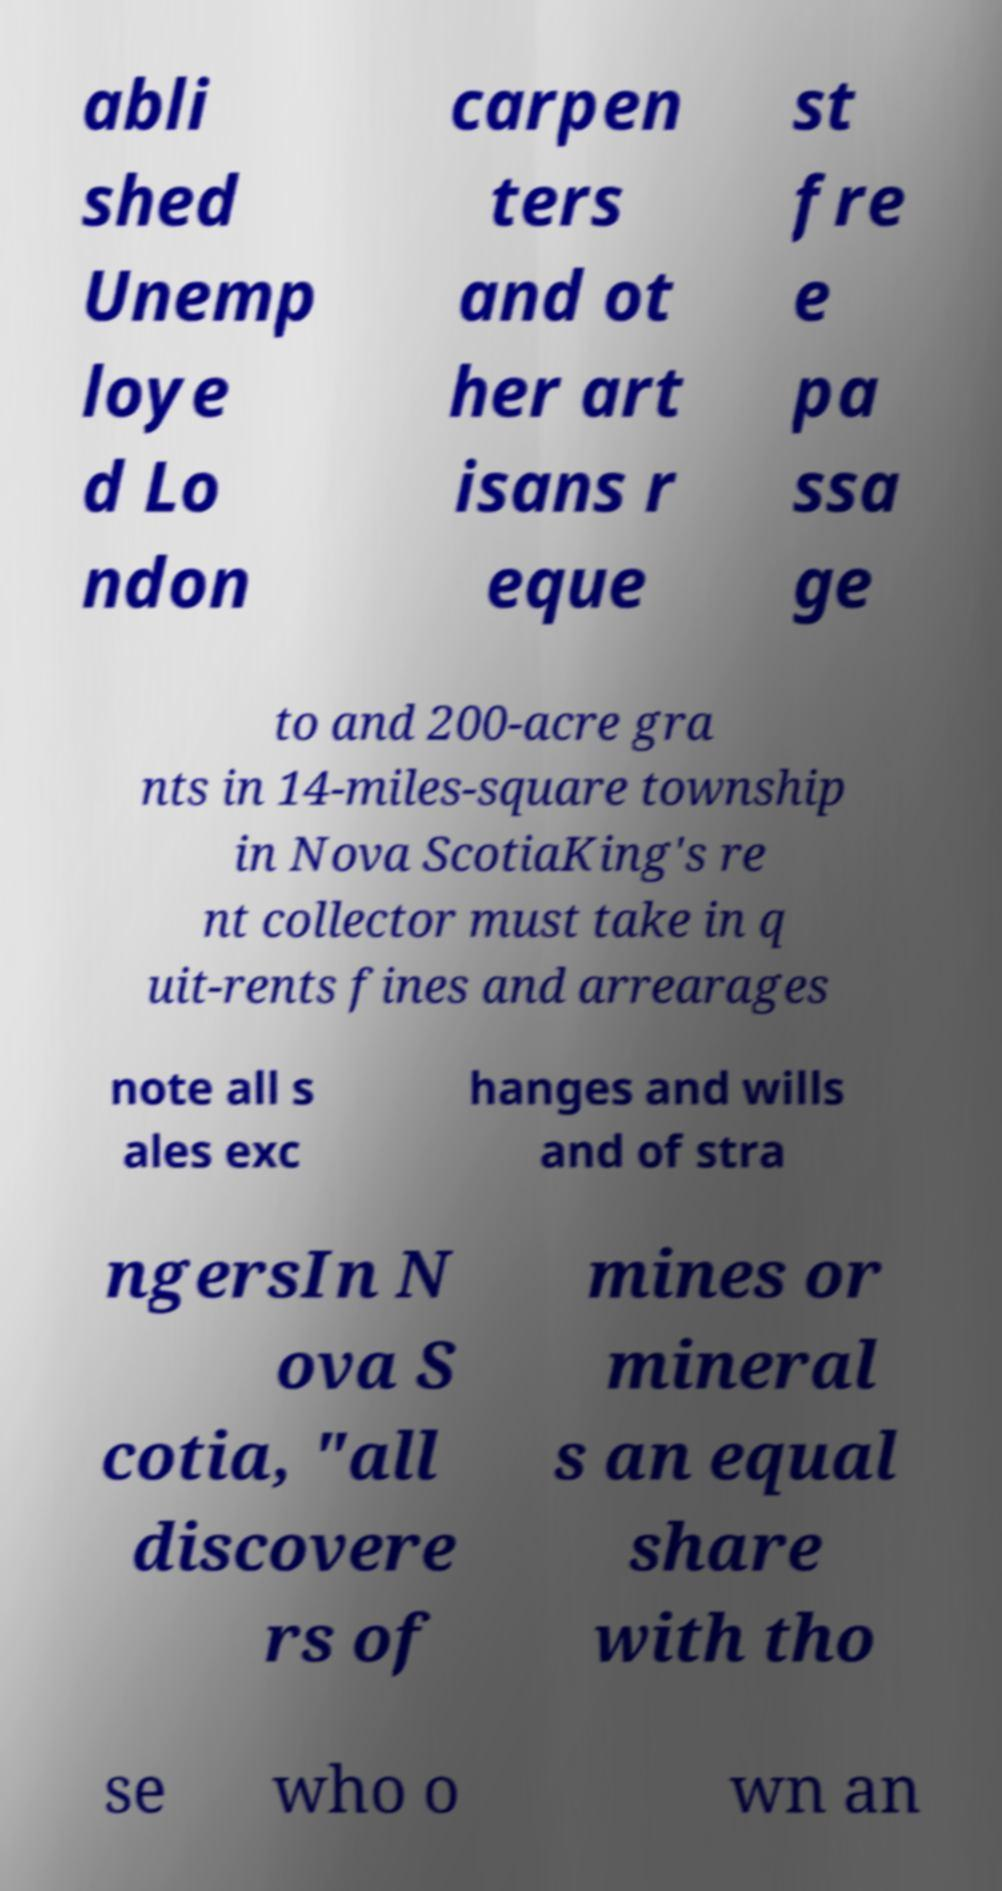Can you read and provide the text displayed in the image?This photo seems to have some interesting text. Can you extract and type it out for me? abli shed Unemp loye d Lo ndon carpen ters and ot her art isans r eque st fre e pa ssa ge to and 200-acre gra nts in 14-miles-square township in Nova ScotiaKing's re nt collector must take in q uit-rents fines and arrearages note all s ales exc hanges and wills and of stra ngersIn N ova S cotia, "all discovere rs of mines or mineral s an equal share with tho se who o wn an 